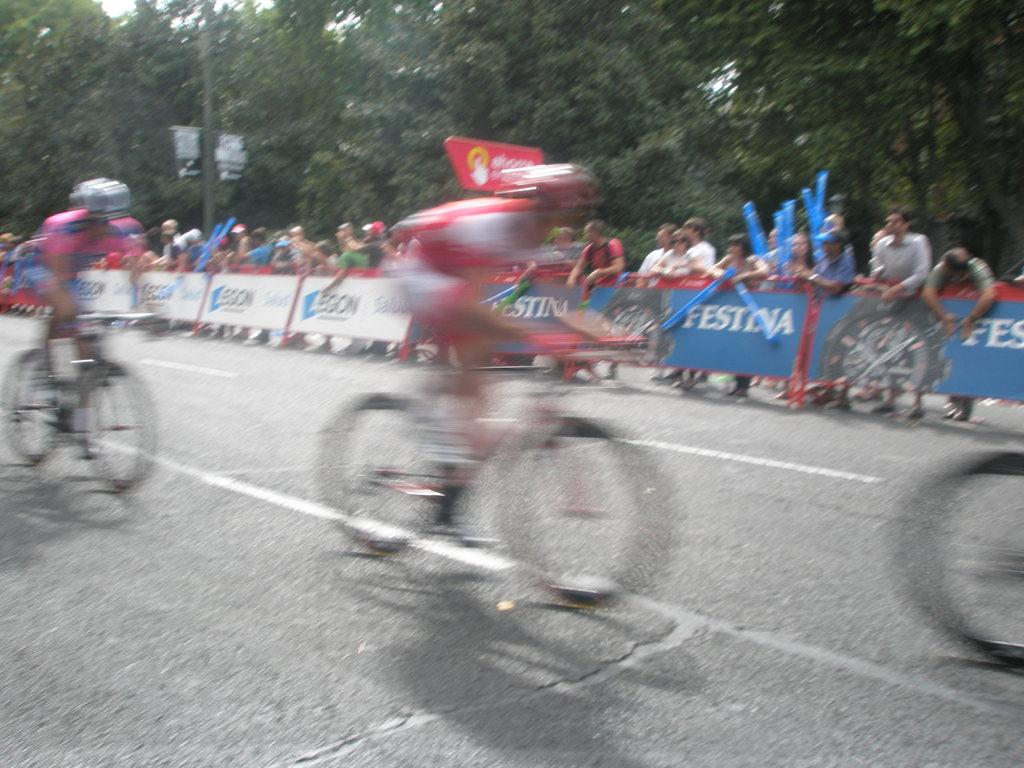What are the people in the image doing? The people in the image are riding bicycles on the road. Are there any other people in the image? Yes, there are people standing beside a fence. What can be seen in the background of the image? Trees are visible in the background of the image. How many spies are hiding behind the trees in the image? There are no spies present in the image; it only features people riding bicycles and standing beside a fence, with trees visible in the background. 